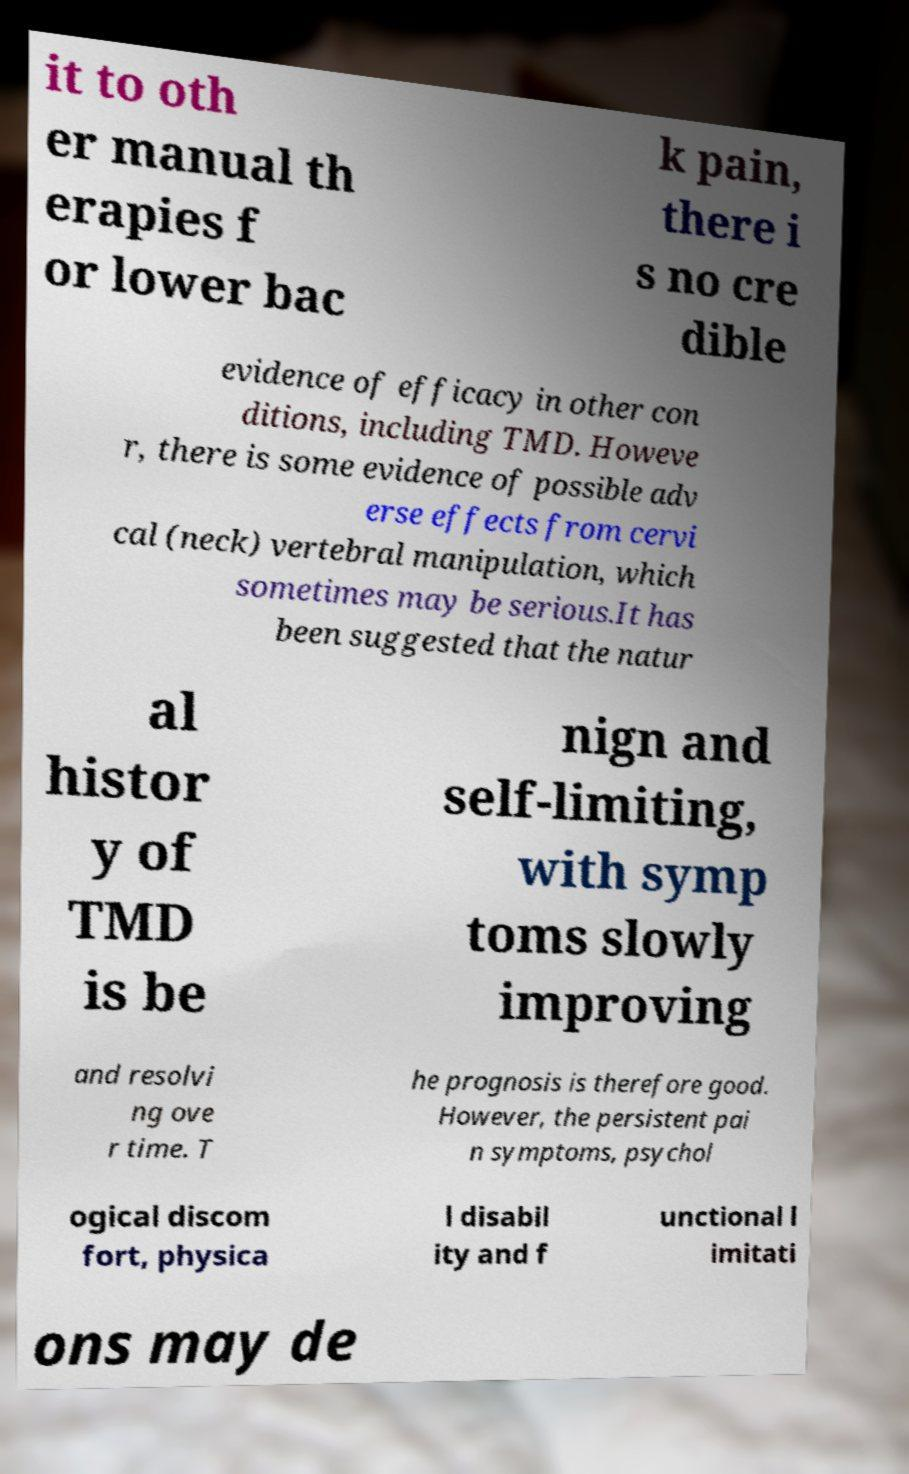Could you assist in decoding the text presented in this image and type it out clearly? it to oth er manual th erapies f or lower bac k pain, there i s no cre dible evidence of efficacy in other con ditions, including TMD. Howeve r, there is some evidence of possible adv erse effects from cervi cal (neck) vertebral manipulation, which sometimes may be serious.It has been suggested that the natur al histor y of TMD is be nign and self-limiting, with symp toms slowly improving and resolvi ng ove r time. T he prognosis is therefore good. However, the persistent pai n symptoms, psychol ogical discom fort, physica l disabil ity and f unctional l imitati ons may de 